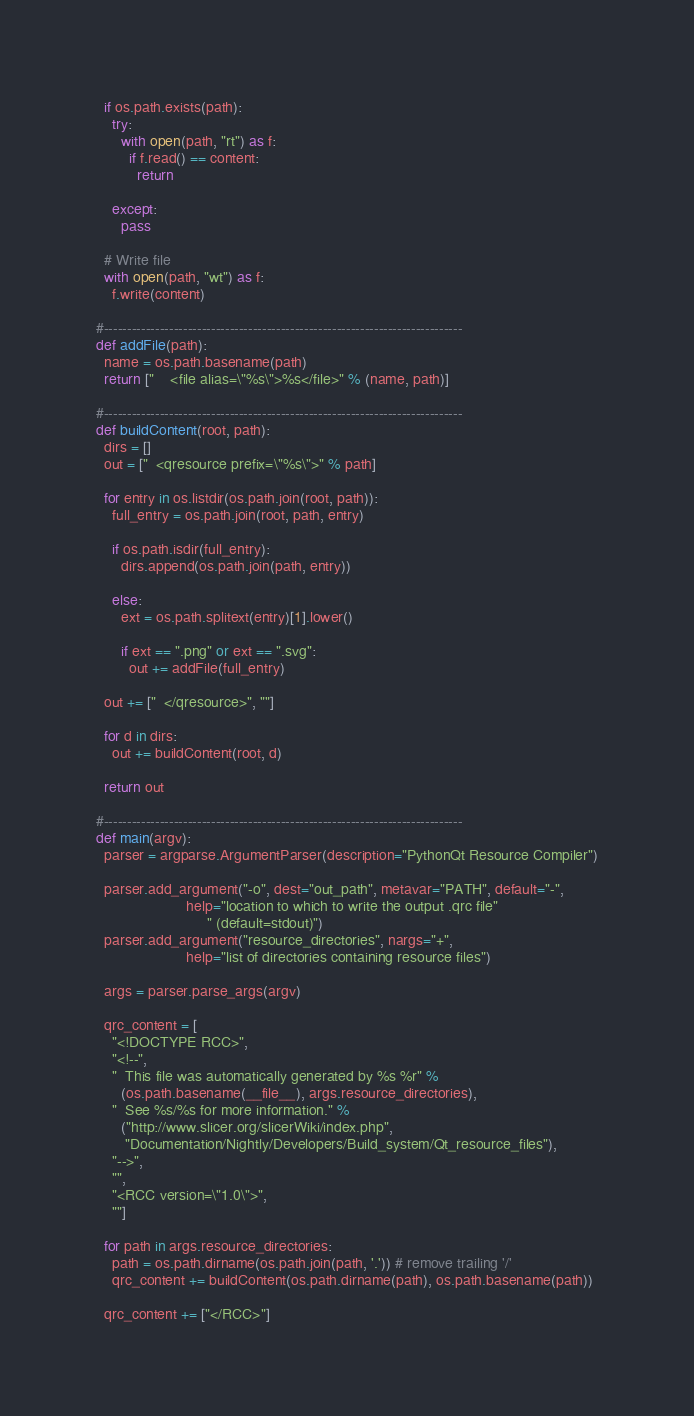<code> <loc_0><loc_0><loc_500><loc_500><_Python_>  if os.path.exists(path):
    try:
      with open(path, "rt") as f:
        if f.read() == content:
          return

    except:
      pass

  # Write file
  with open(path, "wt") as f:
    f.write(content)

#-----------------------------------------------------------------------------
def addFile(path):
  name = os.path.basename(path)
  return ["    <file alias=\"%s\">%s</file>" % (name, path)]

#-----------------------------------------------------------------------------
def buildContent(root, path):
  dirs = []
  out = ["  <qresource prefix=\"%s\">" % path]

  for entry in os.listdir(os.path.join(root, path)):
    full_entry = os.path.join(root, path, entry)

    if os.path.isdir(full_entry):
      dirs.append(os.path.join(path, entry))

    else:
      ext = os.path.splitext(entry)[1].lower()

      if ext == ".png" or ext == ".svg":
        out += addFile(full_entry)

  out += ["  </qresource>", ""]

  for d in dirs:
    out += buildContent(root, d)

  return out

#-----------------------------------------------------------------------------
def main(argv):
  parser = argparse.ArgumentParser(description="PythonQt Resource Compiler")

  parser.add_argument("-o", dest="out_path", metavar="PATH", default="-",
                      help="location to which to write the output .qrc file"
                           " (default=stdout)")
  parser.add_argument("resource_directories", nargs="+",
                      help="list of directories containing resource files")

  args = parser.parse_args(argv)

  qrc_content = [
    "<!DOCTYPE RCC>",
    "<!--",
    "  This file was automatically generated by %s %r" %
      (os.path.basename(__file__), args.resource_directories),
    "  See %s/%s for more information." %
      ("http://www.slicer.org/slicerWiki/index.php",
       "Documentation/Nightly/Developers/Build_system/Qt_resource_files"),
    "-->",
    "",
    "<RCC version=\"1.0\">",
    ""]

  for path in args.resource_directories:
    path = os.path.dirname(os.path.join(path, '.')) # remove trailing '/'
    qrc_content += buildContent(os.path.dirname(path), os.path.basename(path))

  qrc_content += ["</RCC>"]
</code> 